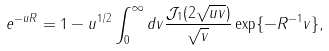<formula> <loc_0><loc_0><loc_500><loc_500>e ^ { - u R } = 1 - u ^ { 1 / 2 } \int _ { 0 } ^ { \infty } d v \frac { \mathcal { J } _ { 1 } ( 2 \sqrt { u v } ) } { \sqrt { v } } \exp \{ - R ^ { - 1 } v \} ,</formula> 